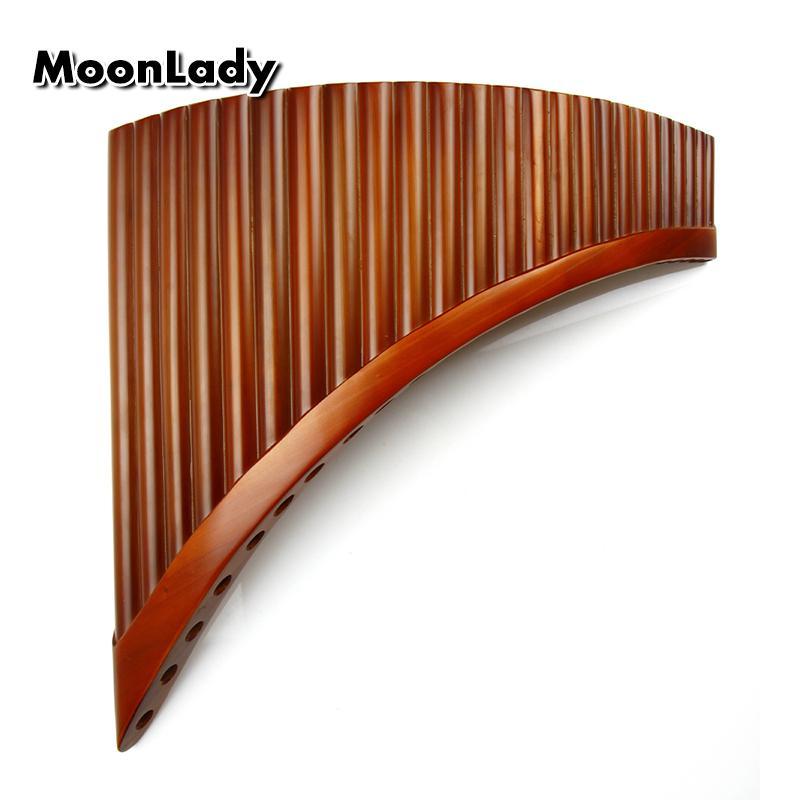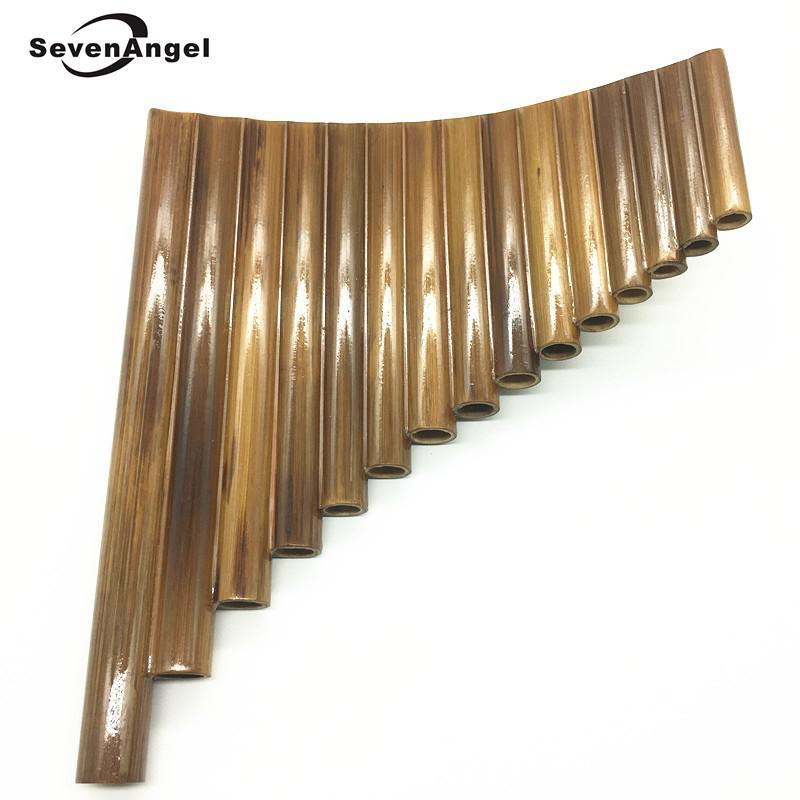The first image is the image on the left, the second image is the image on the right. Considering the images on both sides, is "Each image shows an instrument displayed with its aligned ends at the top, and its tallest 'tube' at the left." valid? Answer yes or no. Yes. The first image is the image on the left, the second image is the image on the right. For the images shown, is this caption "Each instrument is curved." true? Answer yes or no. Yes. 